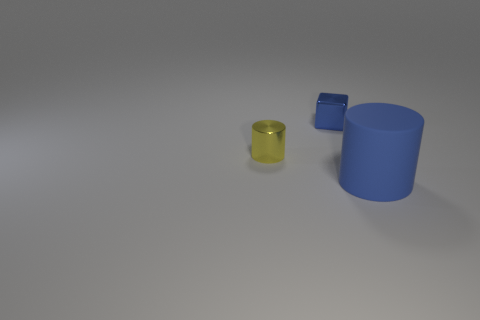Is there any other thing that has the same size as the rubber thing?
Your response must be concise. No. How many other objects are the same size as the blue matte cylinder?
Provide a succinct answer. 0. How big is the thing that is both in front of the blue metal thing and on the right side of the metal cylinder?
Your answer should be very brief. Large. What number of yellow matte things are the same shape as the small yellow metallic object?
Keep it short and to the point. 0. What is the large blue cylinder made of?
Provide a short and direct response. Rubber. Is the tiny yellow metallic object the same shape as the large blue thing?
Give a very brief answer. Yes. Is there a large red cube made of the same material as the blue cube?
Provide a succinct answer. No. What color is the object that is both in front of the small blue shiny cube and on the left side of the rubber object?
Offer a terse response. Yellow. There is a cylinder behind the big blue rubber cylinder; what is its material?
Keep it short and to the point. Metal. Is there a big rubber thing that has the same shape as the tiny yellow metallic object?
Provide a short and direct response. Yes. 